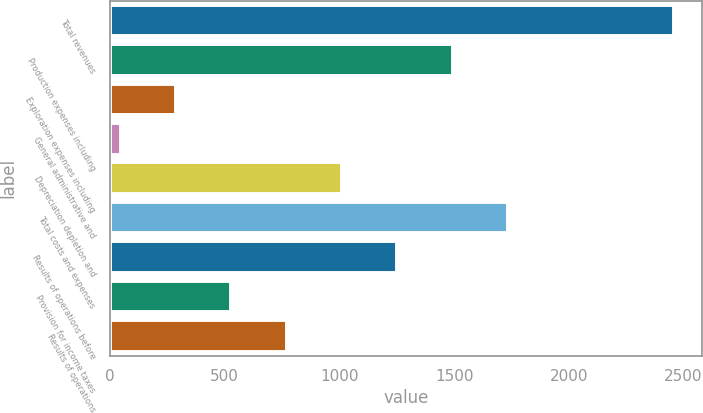Convert chart. <chart><loc_0><loc_0><loc_500><loc_500><bar_chart><fcel>Total revenues<fcel>Production expenses including<fcel>Exploration expenses including<fcel>General administrative and<fcel>Depreciation depletion and<fcel>Total costs and expenses<fcel>Results of operations before<fcel>Provision for income taxes<fcel>Results of operations<nl><fcel>2460<fcel>1494.4<fcel>287.4<fcel>46<fcel>1011.6<fcel>1735.8<fcel>1253<fcel>528.8<fcel>770.2<nl></chart> 